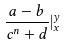Convert formula to latex. <formula><loc_0><loc_0><loc_500><loc_500>\frac { a - b } { c ^ { n } + d } | _ { x } ^ { y }</formula> 